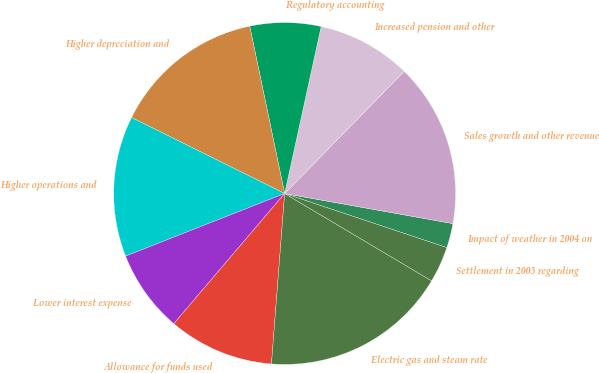Convert chart to OTSL. <chart><loc_0><loc_0><loc_500><loc_500><pie_chart><fcel>Impact of weather in 2004 on<fcel>Sales growth and other revenue<fcel>Increased pension and other<fcel>Regulatory accounting<fcel>Higher depreciation and<fcel>Higher operations and<fcel>Lower interest expense<fcel>Allowance for funds used<fcel>Electric gas and steam rate<fcel>Settlement in 2003 regarding<nl><fcel>2.31%<fcel>15.49%<fcel>8.9%<fcel>6.7%<fcel>14.39%<fcel>13.3%<fcel>7.8%<fcel>10.0%<fcel>17.69%<fcel>3.41%<nl></chart> 